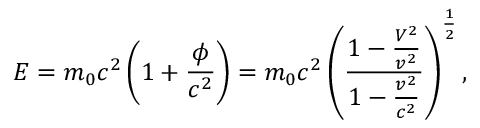<formula> <loc_0><loc_0><loc_500><loc_500>E = m _ { 0 } c ^ { 2 } \left ( 1 + \frac { \phi } { c ^ { 2 } } \right ) = m _ { 0 } c ^ { 2 } \left ( \frac { { 1 - \frac { V ^ { 2 } } { v ^ { 2 } } } } { { 1 - \frac { v ^ { 2 } } { c ^ { 2 } } } } \right ) ^ { \frac { 1 } { 2 } } ,</formula> 